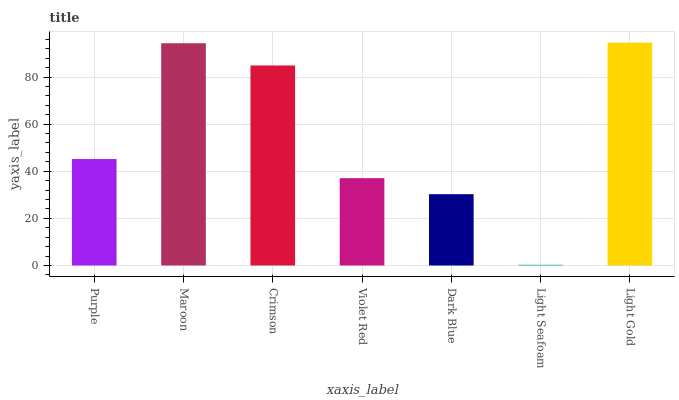Is Light Seafoam the minimum?
Answer yes or no. Yes. Is Light Gold the maximum?
Answer yes or no. Yes. Is Maroon the minimum?
Answer yes or no. No. Is Maroon the maximum?
Answer yes or no. No. Is Maroon greater than Purple?
Answer yes or no. Yes. Is Purple less than Maroon?
Answer yes or no. Yes. Is Purple greater than Maroon?
Answer yes or no. No. Is Maroon less than Purple?
Answer yes or no. No. Is Purple the high median?
Answer yes or no. Yes. Is Purple the low median?
Answer yes or no. Yes. Is Light Seafoam the high median?
Answer yes or no. No. Is Maroon the low median?
Answer yes or no. No. 